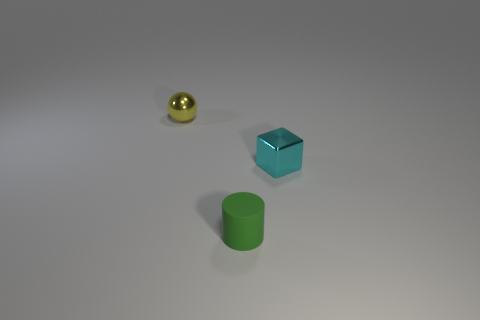Add 1 tiny green matte cylinders. How many objects exist? 4 Subtract all balls. How many objects are left? 2 Subtract 0 purple blocks. How many objects are left? 3 Subtract all tiny purple shiny spheres. Subtract all small metal objects. How many objects are left? 1 Add 1 rubber cylinders. How many rubber cylinders are left? 2 Add 2 tiny cylinders. How many tiny cylinders exist? 3 